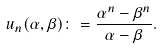Convert formula to latex. <formula><loc_0><loc_0><loc_500><loc_500>u _ { n } ( \alpha , \beta ) \colon = \frac { \alpha ^ { n } - \beta ^ { n } } { \alpha - \beta } .</formula> 